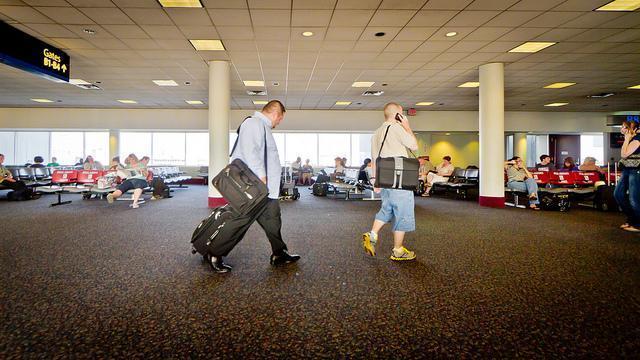How many people are there?
Give a very brief answer. 4. How many dark umbrellas are there?
Give a very brief answer. 0. 